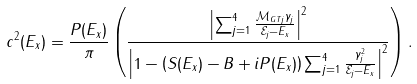<formula> <loc_0><loc_0><loc_500><loc_500>c ^ { 2 } ( E _ { x } ) = \frac { P ( E _ { x } ) } { \pi } \left ( \frac { \left | \sum _ { j = 1 } ^ { 4 } \frac { \mathcal { M } _ { G T j } \gamma _ { j } } { \mathcal { E } _ { j } - E _ { x } } \right | ^ { 2 } } { \left | 1 - \left ( S ( E _ { x } ) - B + i P ( E _ { x } ) \right ) \sum _ { j = 1 } ^ { 4 } \frac { \gamma _ { j } ^ { 2 } } { \mathcal { E } _ { j } - E _ { x } } \right | ^ { 2 } } \right ) .</formula> 